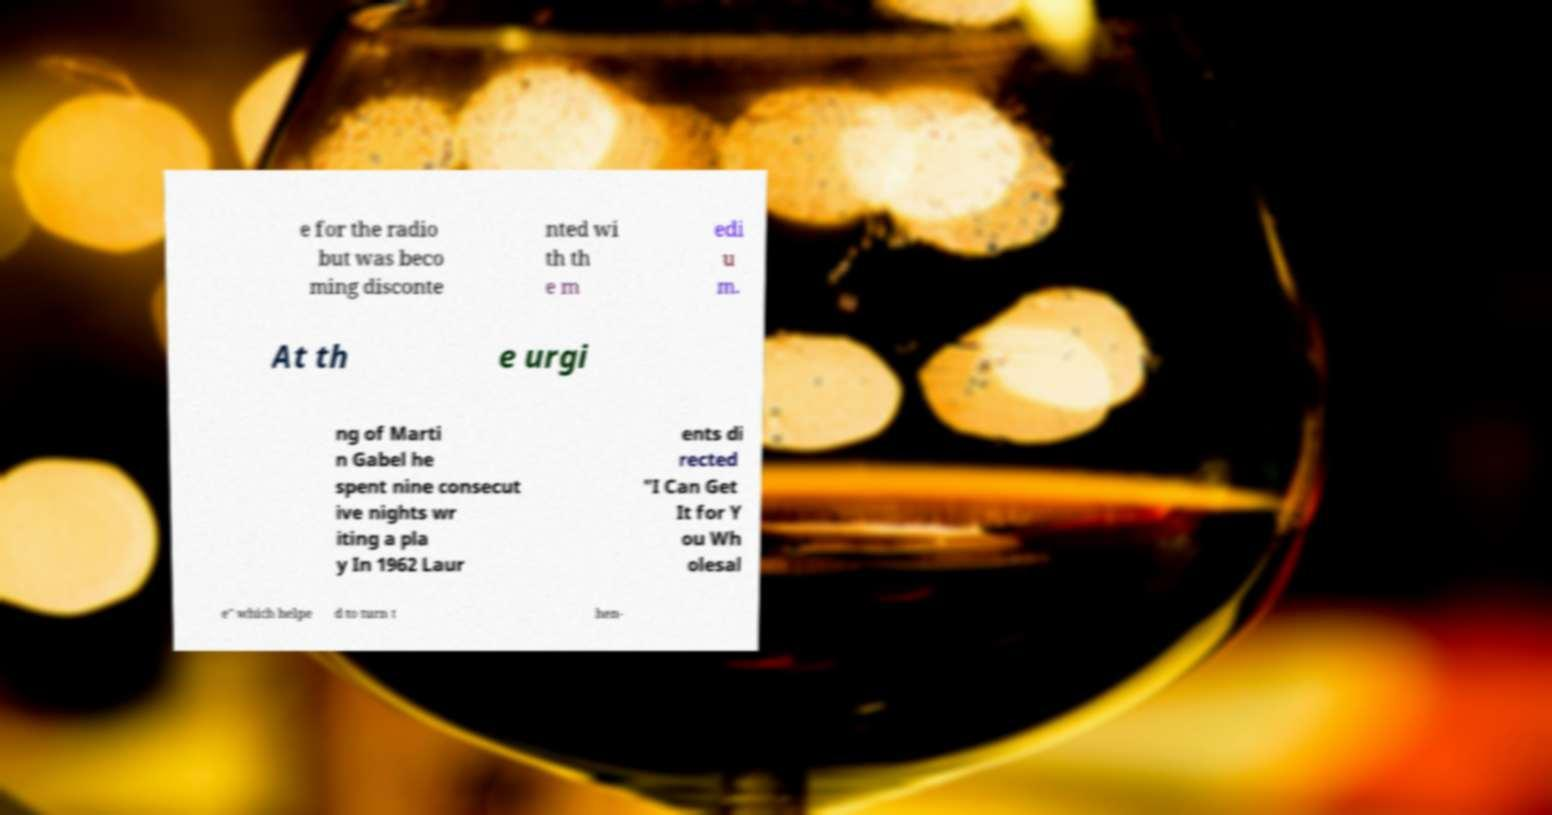Please identify and transcribe the text found in this image. e for the radio but was beco ming disconte nted wi th th e m edi u m. At th e urgi ng of Marti n Gabel he spent nine consecut ive nights wr iting a pla y In 1962 Laur ents di rected "I Can Get It for Y ou Wh olesal e" which helpe d to turn t hen- 